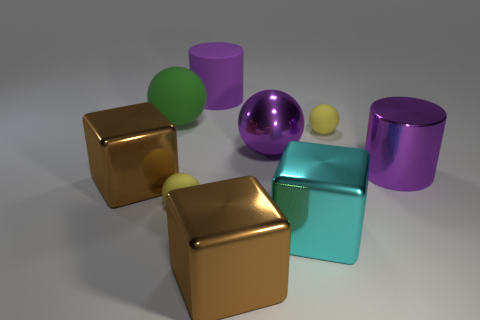Subtract 1 balls. How many balls are left? 3 Add 1 red matte balls. How many objects exist? 10 Subtract all cylinders. How many objects are left? 7 Add 2 purple rubber objects. How many purple rubber objects exist? 3 Subtract 1 cyan cubes. How many objects are left? 8 Subtract all large brown cubes. Subtract all purple balls. How many objects are left? 6 Add 3 large brown shiny things. How many large brown shiny things are left? 5 